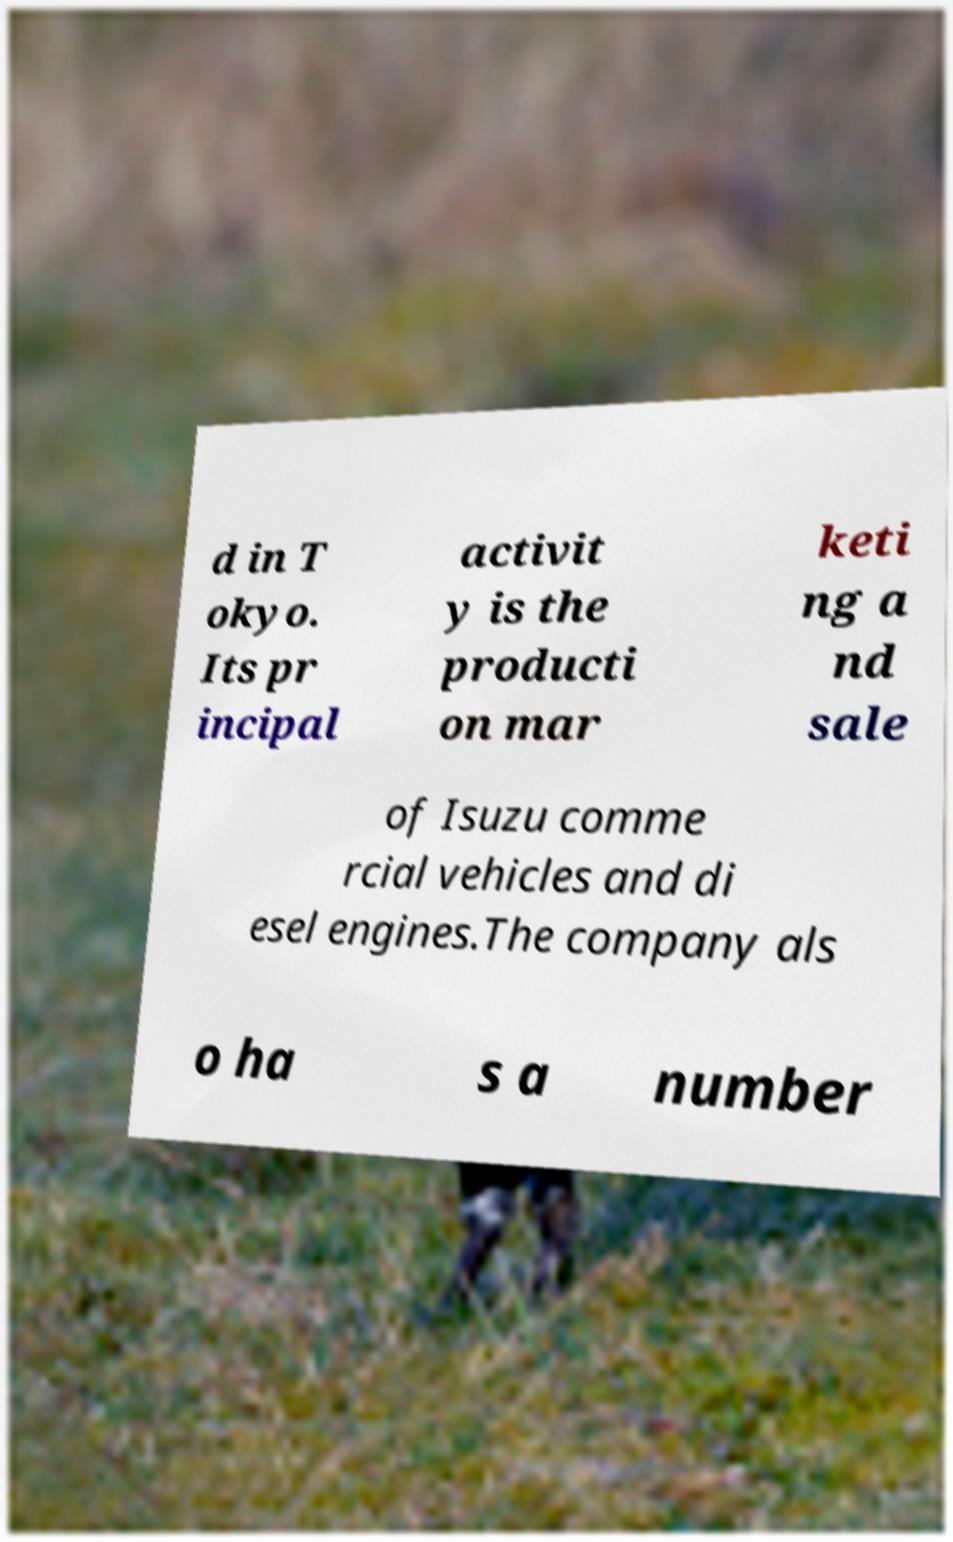There's text embedded in this image that I need extracted. Can you transcribe it verbatim? d in T okyo. Its pr incipal activit y is the producti on mar keti ng a nd sale of Isuzu comme rcial vehicles and di esel engines.The company als o ha s a number 